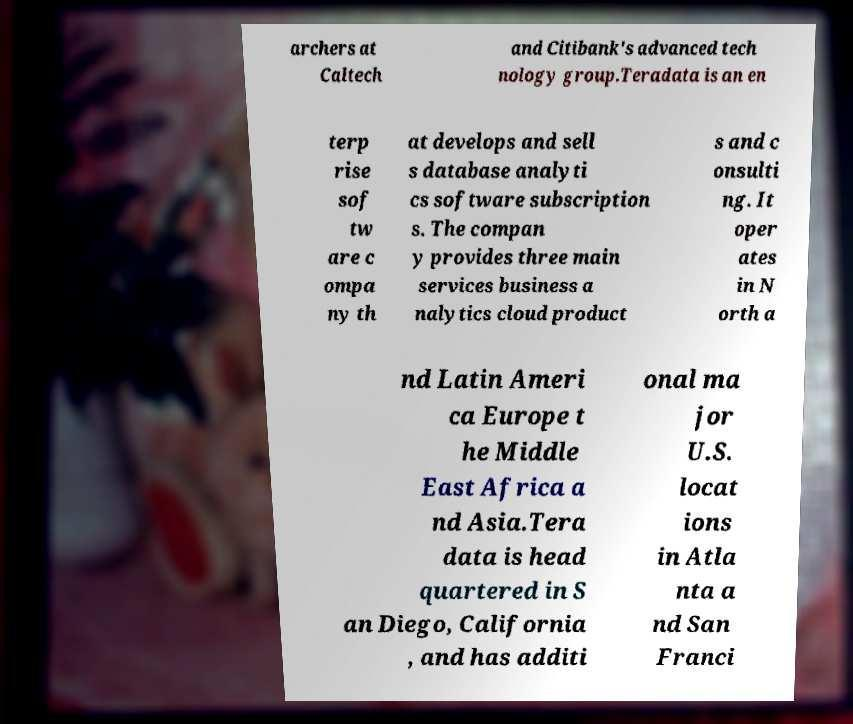Could you assist in decoding the text presented in this image and type it out clearly? archers at Caltech and Citibank's advanced tech nology group.Teradata is an en terp rise sof tw are c ompa ny th at develops and sell s database analyti cs software subscription s. The compan y provides three main services business a nalytics cloud product s and c onsulti ng. It oper ates in N orth a nd Latin Ameri ca Europe t he Middle East Africa a nd Asia.Tera data is head quartered in S an Diego, California , and has additi onal ma jor U.S. locat ions in Atla nta a nd San Franci 